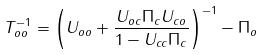Convert formula to latex. <formula><loc_0><loc_0><loc_500><loc_500>T _ { o o } ^ { - 1 } = \left ( U _ { o o } + \frac { U _ { o c } \Pi _ { c } U _ { c o } } { 1 - U _ { c c } \Pi _ { c } } \right ) ^ { - 1 } - \Pi _ { o }</formula> 